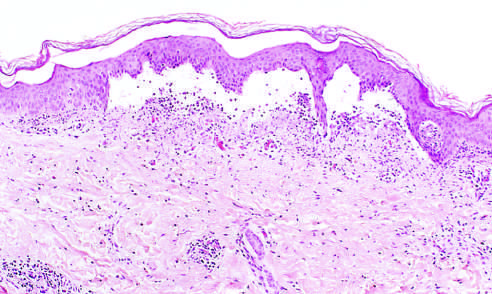how does low-power view of a cross section of a skin blister show the epidermis separated from the dermis?
Answer the question using a single word or phrase. By a focal collection serous effusion 